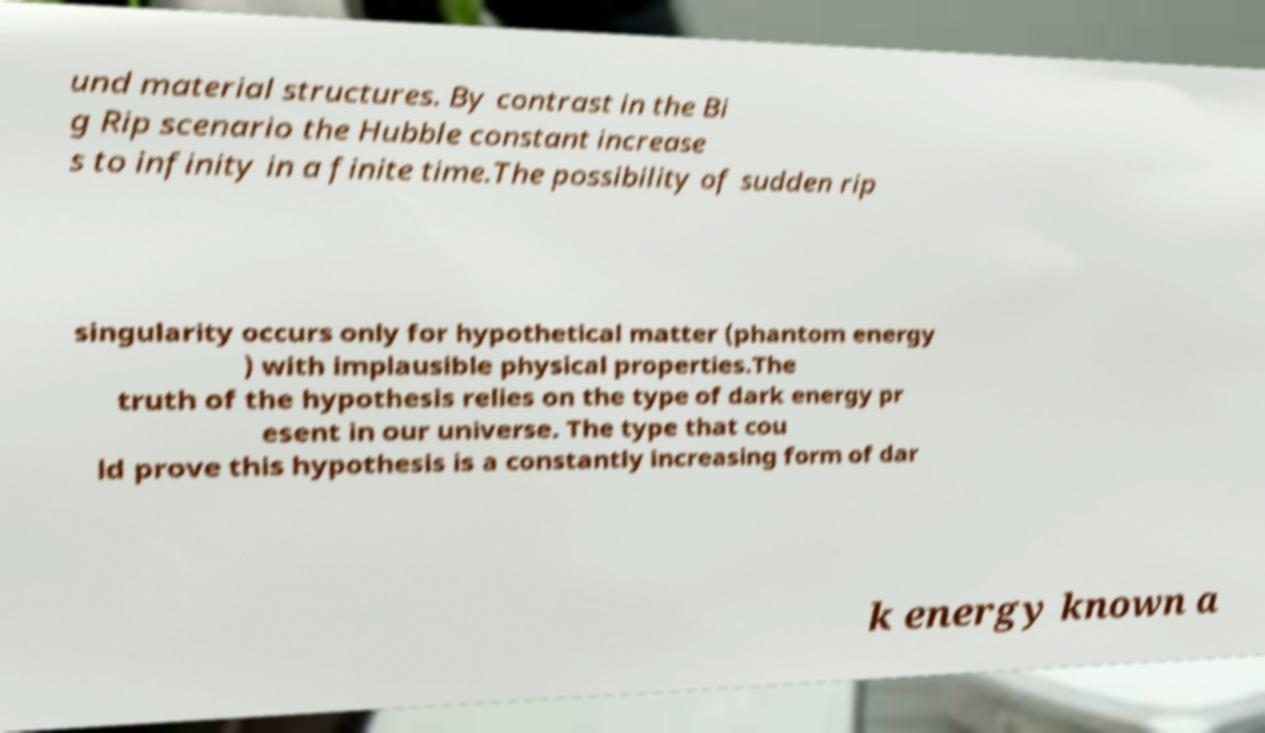Please identify and transcribe the text found in this image. und material structures. By contrast in the Bi g Rip scenario the Hubble constant increase s to infinity in a finite time.The possibility of sudden rip singularity occurs only for hypothetical matter (phantom energy ) with implausible physical properties.The truth of the hypothesis relies on the type of dark energy pr esent in our universe. The type that cou ld prove this hypothesis is a constantly increasing form of dar k energy known a 